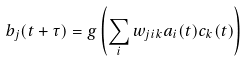<formula> <loc_0><loc_0><loc_500><loc_500>b _ { j } ( t + \tau ) = g \left ( \sum _ { i } w _ { j i k } a _ { i } ( t ) c _ { k } ( t ) \right )</formula> 